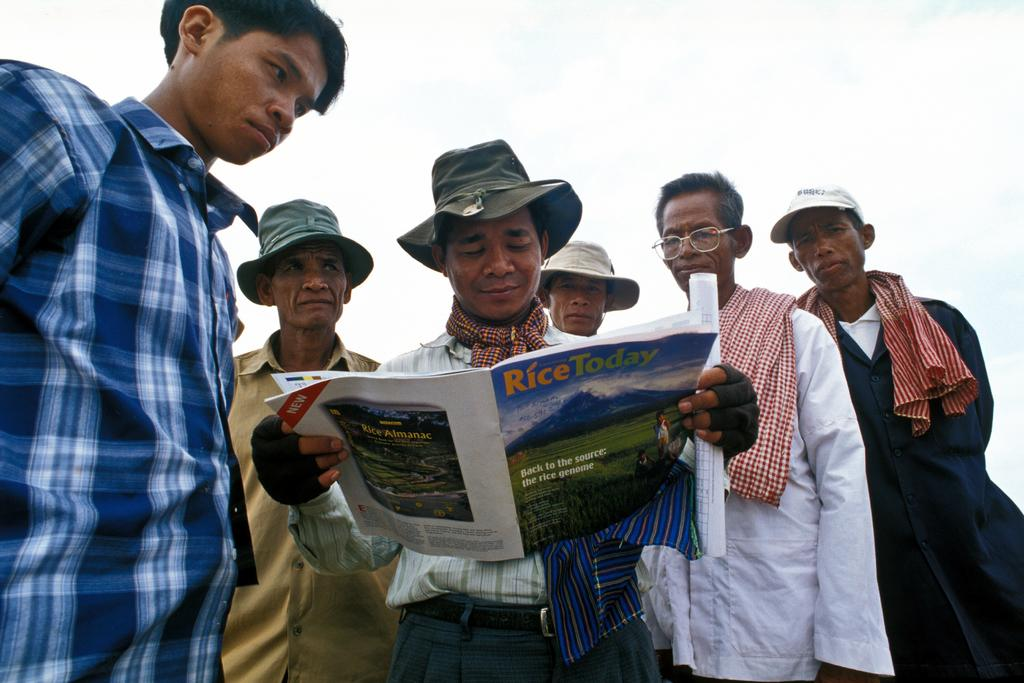What is the main subject of the image? The main subject of the image is a group of people. Can you describe any specific details about the people in the image? Some men in the group are wearing caps. What is one man in the group holding in his hands? One man is holding a book and a paper in his hands. What can be seen at the top of the image? The sky is visible at the top of the image. How many buns are being sold in the store depicted in the image? There is no store or buns present in the image; it features a group of people. What type of pigs can be seen interacting with the people in the image? There are no pigs present in the image; it features a group of people. 